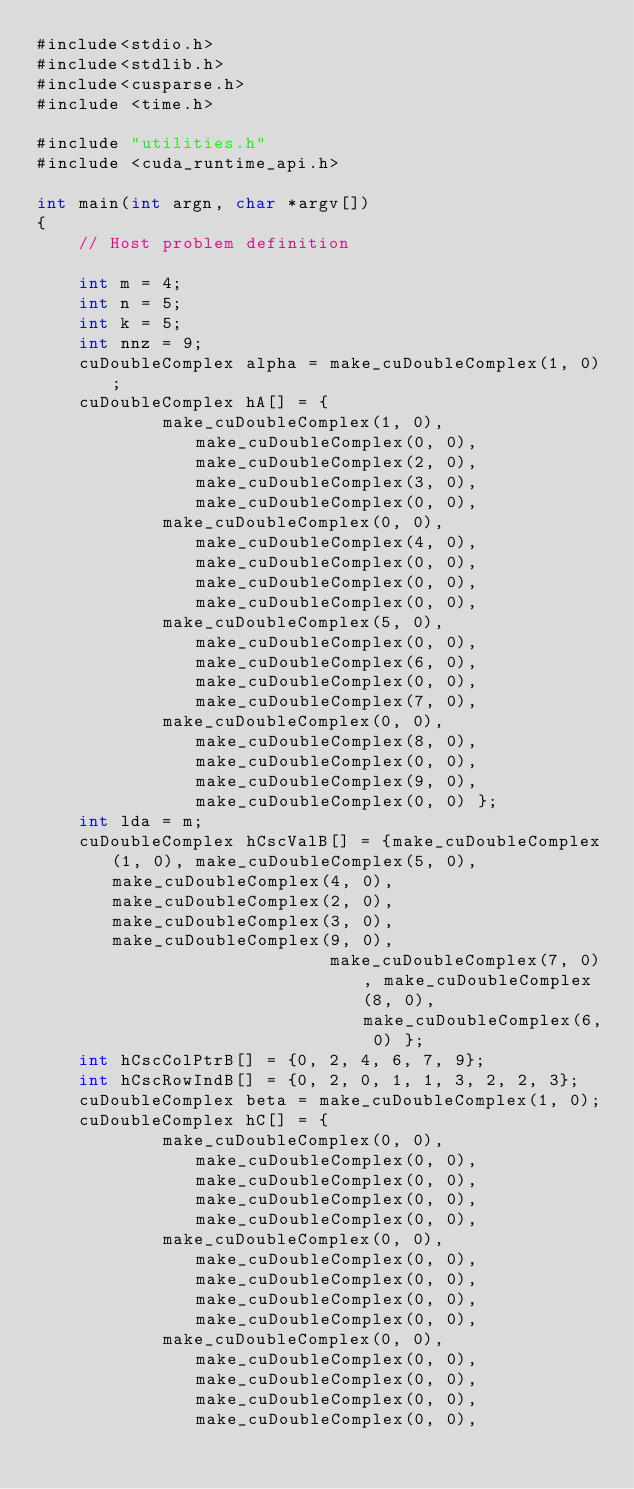Convert code to text. <code><loc_0><loc_0><loc_500><loc_500><_Cuda_>#include<stdio.h>
#include<stdlib.h>
#include<cusparse.h>
#include <time.h>

#include "utilities.h"
#include <cuda_runtime_api.h>

int main(int argn, char *argv[])
{
    // Host problem definition

    int m = 4;
    int n = 5;
    int k = 5;
    int nnz = 9;
    cuDoubleComplex alpha = make_cuDoubleComplex(1, 0);
    cuDoubleComplex hA[] = {
            make_cuDoubleComplex(1, 0), make_cuDoubleComplex(0, 0), make_cuDoubleComplex(2, 0), make_cuDoubleComplex(3, 0), make_cuDoubleComplex(0, 0),
            make_cuDoubleComplex(0, 0), make_cuDoubleComplex(4, 0), make_cuDoubleComplex(0, 0), make_cuDoubleComplex(0, 0), make_cuDoubleComplex(0, 0),
            make_cuDoubleComplex(5, 0), make_cuDoubleComplex(0, 0), make_cuDoubleComplex(6, 0), make_cuDoubleComplex(0, 0), make_cuDoubleComplex(7, 0),
            make_cuDoubleComplex(0, 0), make_cuDoubleComplex(8, 0), make_cuDoubleComplex(0, 0), make_cuDoubleComplex(9, 0), make_cuDoubleComplex(0, 0) };
    int lda = m;
    cuDoubleComplex hCscValB[] = {make_cuDoubleComplex(1, 0), make_cuDoubleComplex(5, 0), make_cuDoubleComplex(4, 0), make_cuDoubleComplex(2, 0), make_cuDoubleComplex(3, 0), make_cuDoubleComplex(9, 0),
                            make_cuDoubleComplex(7, 0), make_cuDoubleComplex(8, 0), make_cuDoubleComplex(6, 0) };
    int hCscColPtrB[] = {0, 2, 4, 6, 7, 9};
    int hCscRowIndB[] = {0, 2, 0, 1, 1, 3, 2, 2, 3};
    cuDoubleComplex beta = make_cuDoubleComplex(1, 0);
    cuDoubleComplex hC[] = {
            make_cuDoubleComplex(0, 0), make_cuDoubleComplex(0, 0), make_cuDoubleComplex(0, 0), make_cuDoubleComplex(0, 0), make_cuDoubleComplex(0, 0),
            make_cuDoubleComplex(0, 0), make_cuDoubleComplex(0, 0), make_cuDoubleComplex(0, 0), make_cuDoubleComplex(0, 0), make_cuDoubleComplex(0, 0),
            make_cuDoubleComplex(0, 0), make_cuDoubleComplex(0, 0), make_cuDoubleComplex(0, 0), make_cuDoubleComplex(0, 0), make_cuDoubleComplex(0, 0),</code> 